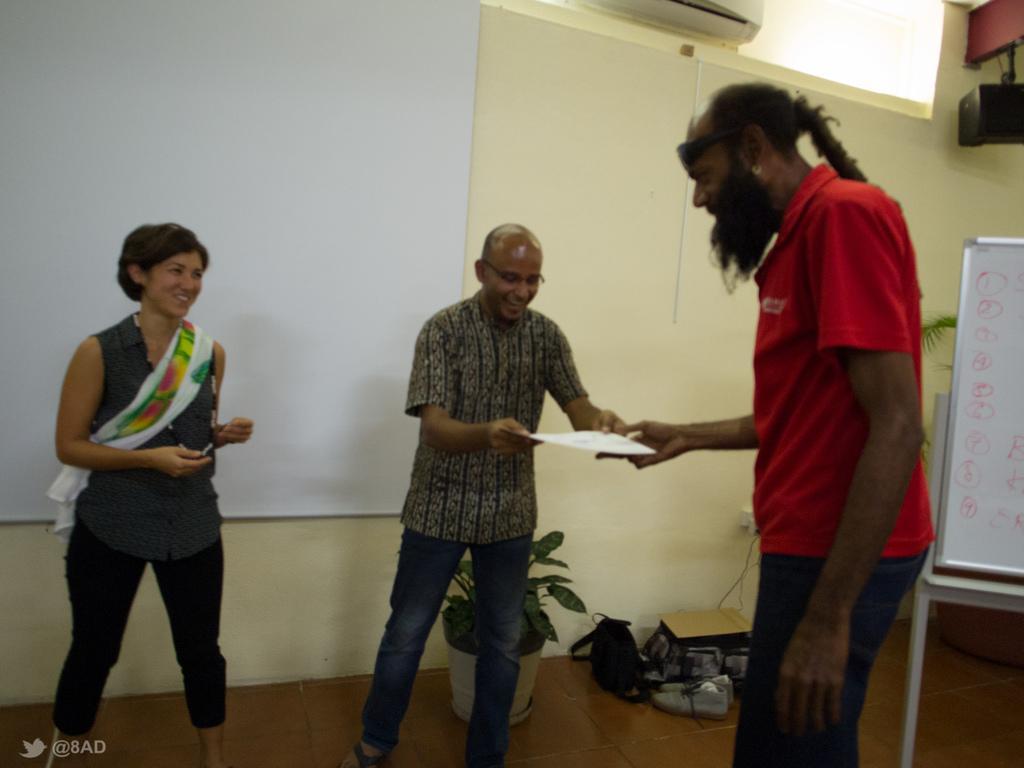Can you describe this image briefly? In this picture I can see 2 men standing in front and holding a paper and beside to them, I can see a woman standing and I see that she is smiling. In the background I can see the wall, a plant, a white color thing and few things on the floor. On the right side of this picture I can see a white board and I see something is written on it. I can also see few leaves behind the board. 